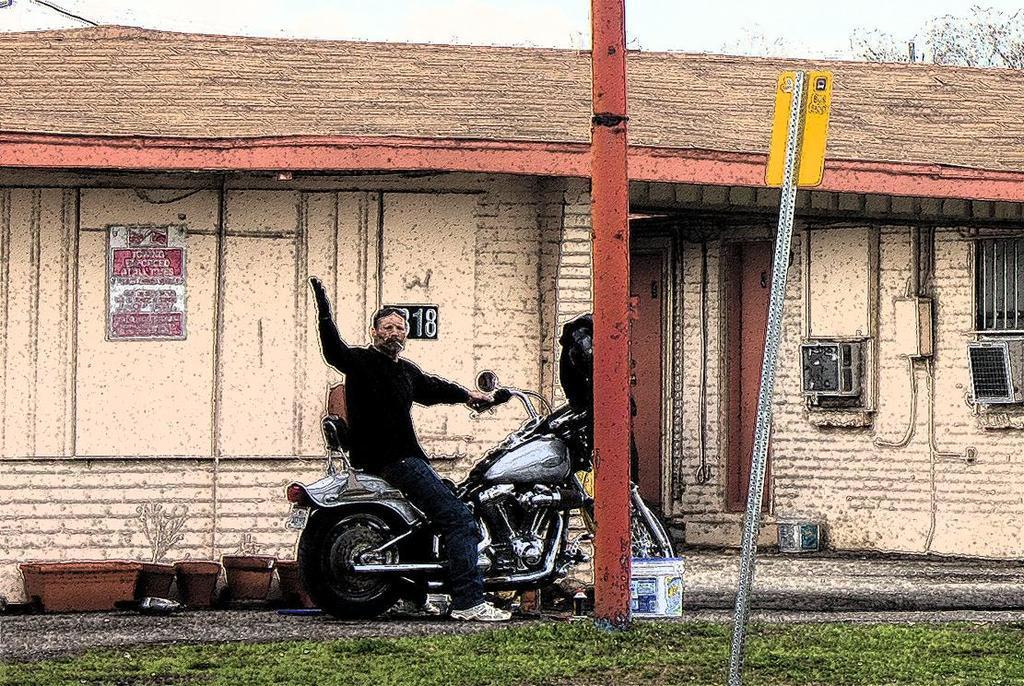Describe this image in one or two sentences. In this image I can see a man is sitting on his bike. In the background I can see a building and a sign board. 